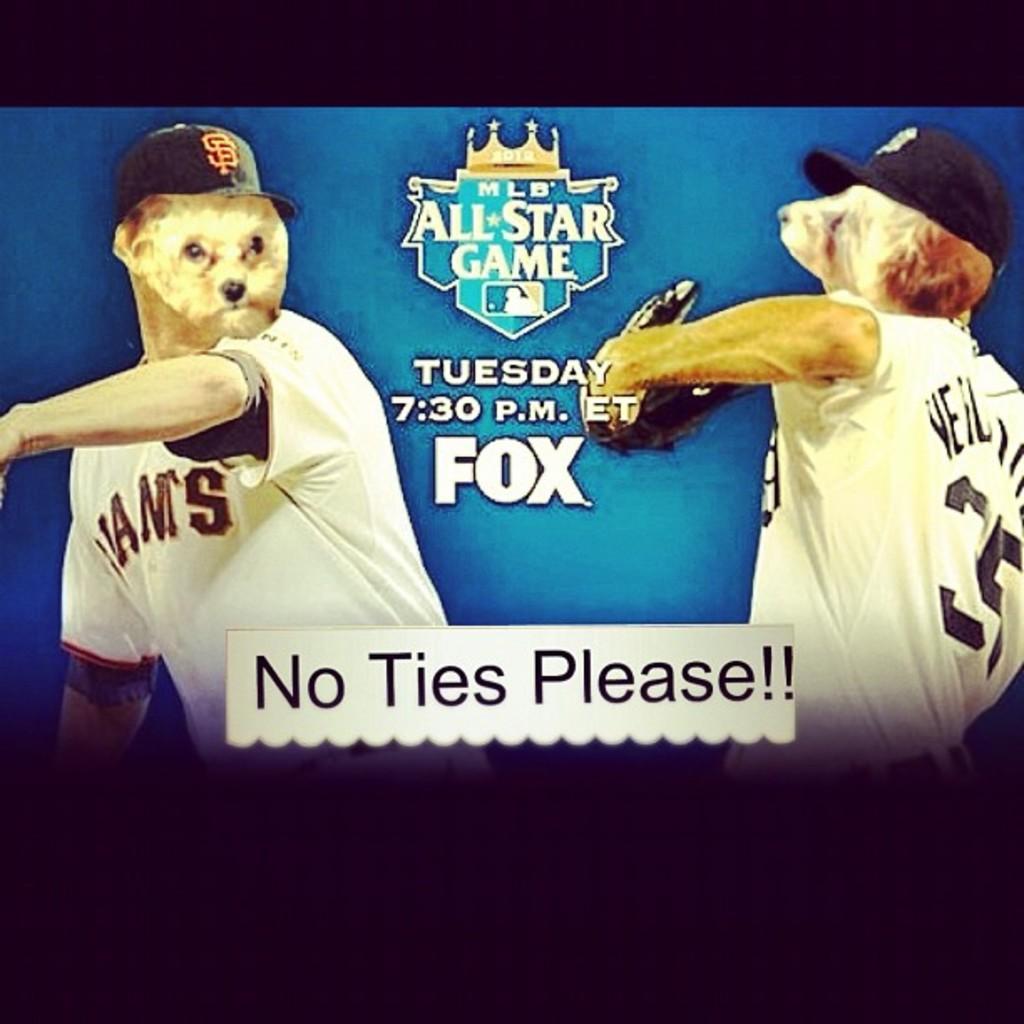What day of the week is the game?
Offer a terse response. Tuesday. What is the poster asking people not to wear?
Make the answer very short. Ties. 